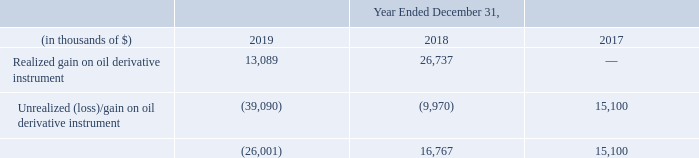In relation to the oil derivative instrument (see note 24), the fair value was determined using the estimated discounted cash flows of the additional payments due to us as a result of oil prices moving above a contractual oil price floor over the term of the liquefaction tolling agreement ("LTA"). Significant inputs used in the valuation of the oil derivative instrument include management’s estimate of an appropriate discount rate and the length of time to blend the long-term and the short-term oil prices obtained from quoted prices in active markets. The changes in fair value of our oil derivative instrument is recognized in each period in current earnings in "Realized and unrealized gain on oil derivative instrument" as part of the consolidated statement of income.
The realized and unrealized (loss)/ gain on the oil derivative instrument is as follows:
The unrealized loss/gain results from movement in oil prices above a contractual floor price over term of the LTA; the realized gain results from monthly billings above the base tolling fee under the LTA. For further information on the nature of this derivative, refer to note 24.
In which years was the realized and unrealized (loss)/ gain on the oil derivative instrument recorded for? 2019, 2018, 2017. How was the fair value of oil derivative instrument determined? Using the estimated discounted cash flows of the additional payments due to us as a result of oil prices moving above a contractual oil price floor over the term of the liquefaction tolling agreement ("lta"). What inputs were used in the valuation of the oil derivative instrument? Management’s estimate of an appropriate discount rate and the length of time to blend the long-term and the short-term oil prices obtained from quoted prices in active markets. In which year was the unrealized loss on oil derivative instrument the highest? (39,090) > (9,970) > 15,100
Answer: 2019. What was the change in realized gain on oil derivative instrument from 2017 to 2018?
Answer scale should be: thousand. 26,737 - 0 
Answer: 26737. What was the percentage change in total realized and unrealized (loss)/ gain on the oil derivative instrument from 2017 to 2018?
Answer scale should be: percent. (16,767 - 15,100)/15,100 
Answer: 11.04. 